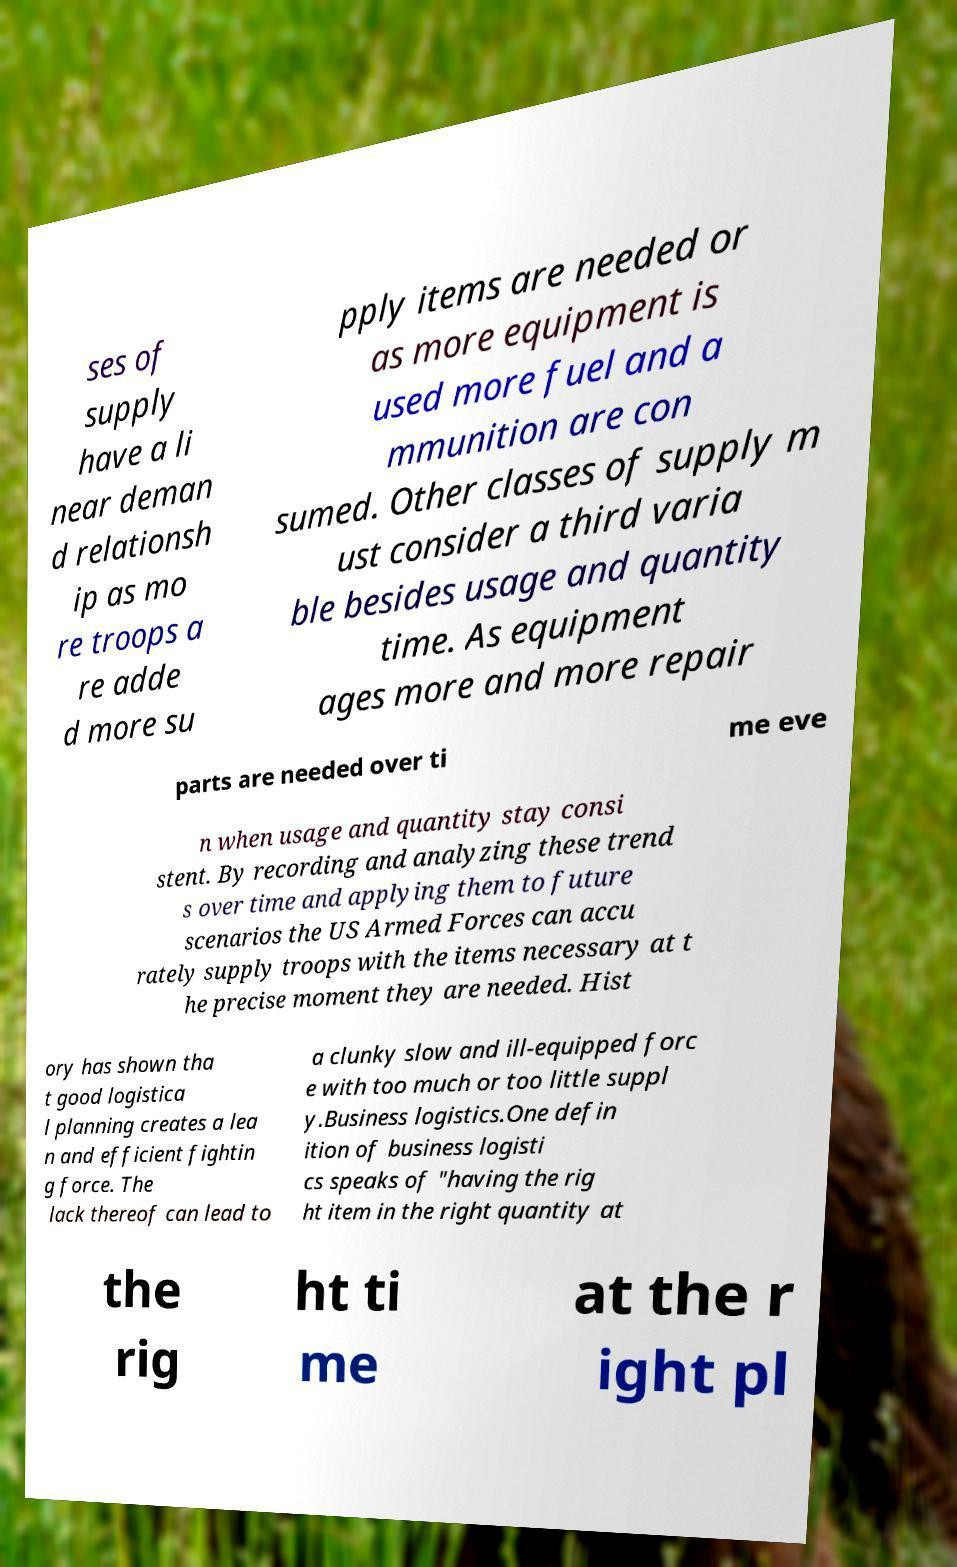Can you read and provide the text displayed in the image?This photo seems to have some interesting text. Can you extract and type it out for me? ses of supply have a li near deman d relationsh ip as mo re troops a re adde d more su pply items are needed or as more equipment is used more fuel and a mmunition are con sumed. Other classes of supply m ust consider a third varia ble besides usage and quantity time. As equipment ages more and more repair parts are needed over ti me eve n when usage and quantity stay consi stent. By recording and analyzing these trend s over time and applying them to future scenarios the US Armed Forces can accu rately supply troops with the items necessary at t he precise moment they are needed. Hist ory has shown tha t good logistica l planning creates a lea n and efficient fightin g force. The lack thereof can lead to a clunky slow and ill-equipped forc e with too much or too little suppl y.Business logistics.One defin ition of business logisti cs speaks of "having the rig ht item in the right quantity at the rig ht ti me at the r ight pl 